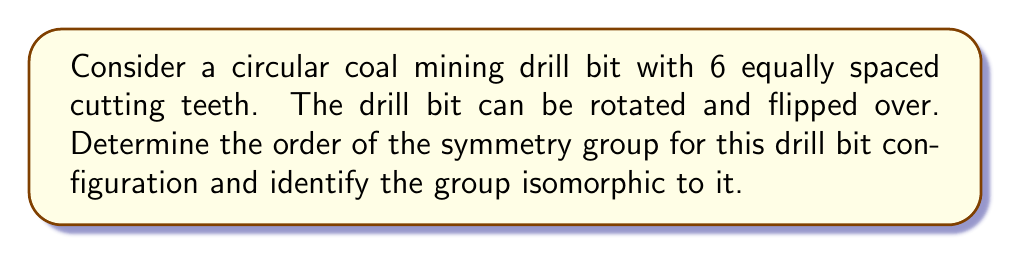What is the answer to this math problem? To analyze the symmetry group of this drill bit, we need to consider all possible transformations that leave the configuration unchanged:

1. Rotations:
   The drill bit has 6 teeth, so it can be rotated by multiples of 60° (360°/6). This gives us 6 distinct rotations (including the identity rotation).

2. Reflections:
   The drill bit can be flipped over, which is equivalent to a reflection. There are 6 lines of reflection (one through each tooth and one between each pair of adjacent teeth).

The total number of symmetries is thus 12 (6 rotations + 6 reflections).

This symmetry group is known as the dihedral group of order 12, denoted as $D_6$ or $D_{12}$ (depending on the notation convention).

Properties of this group:
- It has 12 elements
- It is non-abelian (rotations and reflections don't always commute)
- It can be generated by two elements: a rotation of 60° and a reflection

The group structure can be represented as:
$$D_6 = \langle r, s \mid r^6 = s^2 = 1, srs = r^{-1} \rangle$$

Where $r$ represents a 60° rotation and $s$ represents a reflection.

This group is isomorphic to the symmetry group of a regular hexagon, which makes sense given the 6-fold symmetry of our drill bit.
Answer: The order of the symmetry group is 12, and the group is isomorphic to the dihedral group $D_6$ (or $D_{12}$). 